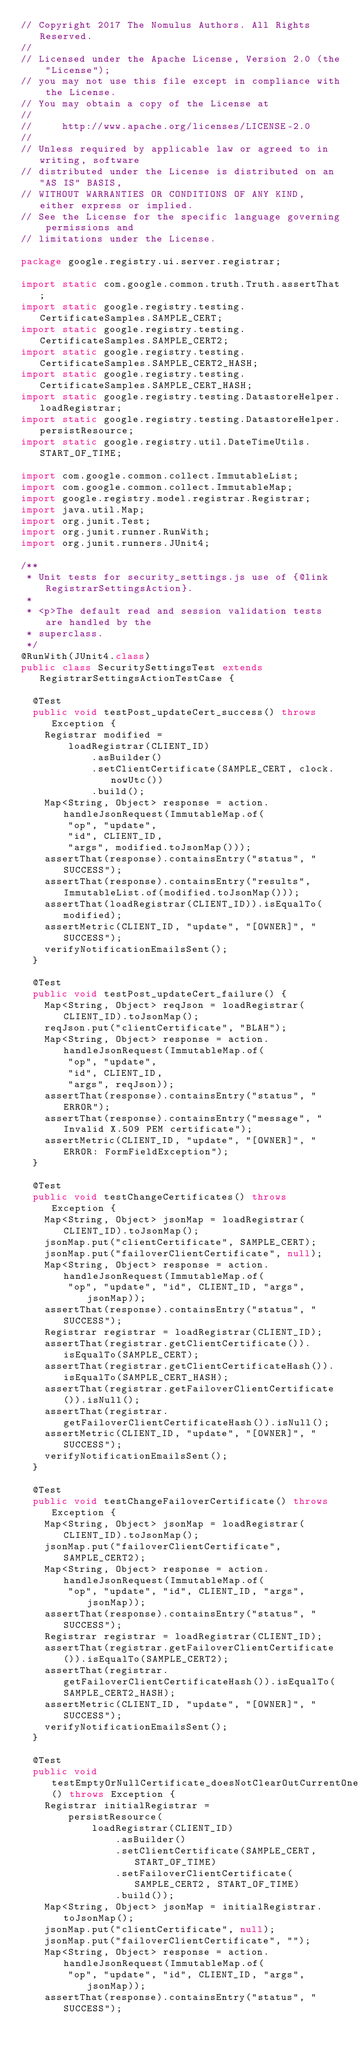Convert code to text. <code><loc_0><loc_0><loc_500><loc_500><_Java_>// Copyright 2017 The Nomulus Authors. All Rights Reserved.
//
// Licensed under the Apache License, Version 2.0 (the "License");
// you may not use this file except in compliance with the License.
// You may obtain a copy of the License at
//
//     http://www.apache.org/licenses/LICENSE-2.0
//
// Unless required by applicable law or agreed to in writing, software
// distributed under the License is distributed on an "AS IS" BASIS,
// WITHOUT WARRANTIES OR CONDITIONS OF ANY KIND, either express or implied.
// See the License for the specific language governing permissions and
// limitations under the License.

package google.registry.ui.server.registrar;

import static com.google.common.truth.Truth.assertThat;
import static google.registry.testing.CertificateSamples.SAMPLE_CERT;
import static google.registry.testing.CertificateSamples.SAMPLE_CERT2;
import static google.registry.testing.CertificateSamples.SAMPLE_CERT2_HASH;
import static google.registry.testing.CertificateSamples.SAMPLE_CERT_HASH;
import static google.registry.testing.DatastoreHelper.loadRegistrar;
import static google.registry.testing.DatastoreHelper.persistResource;
import static google.registry.util.DateTimeUtils.START_OF_TIME;

import com.google.common.collect.ImmutableList;
import com.google.common.collect.ImmutableMap;
import google.registry.model.registrar.Registrar;
import java.util.Map;
import org.junit.Test;
import org.junit.runner.RunWith;
import org.junit.runners.JUnit4;

/**
 * Unit tests for security_settings.js use of {@link RegistrarSettingsAction}.
 *
 * <p>The default read and session validation tests are handled by the
 * superclass.
 */
@RunWith(JUnit4.class)
public class SecuritySettingsTest extends RegistrarSettingsActionTestCase {

  @Test
  public void testPost_updateCert_success() throws Exception {
    Registrar modified =
        loadRegistrar(CLIENT_ID)
            .asBuilder()
            .setClientCertificate(SAMPLE_CERT, clock.nowUtc())
            .build();
    Map<String, Object> response = action.handleJsonRequest(ImmutableMap.of(
        "op", "update",
        "id", CLIENT_ID,
        "args", modified.toJsonMap()));
    assertThat(response).containsEntry("status", "SUCCESS");
    assertThat(response).containsEntry("results", ImmutableList.of(modified.toJsonMap()));
    assertThat(loadRegistrar(CLIENT_ID)).isEqualTo(modified);
    assertMetric(CLIENT_ID, "update", "[OWNER]", "SUCCESS");
    verifyNotificationEmailsSent();
  }

  @Test
  public void testPost_updateCert_failure() {
    Map<String, Object> reqJson = loadRegistrar(CLIENT_ID).toJsonMap();
    reqJson.put("clientCertificate", "BLAH");
    Map<String, Object> response = action.handleJsonRequest(ImmutableMap.of(
        "op", "update",
        "id", CLIENT_ID,
        "args", reqJson));
    assertThat(response).containsEntry("status", "ERROR");
    assertThat(response).containsEntry("message", "Invalid X.509 PEM certificate");
    assertMetric(CLIENT_ID, "update", "[OWNER]", "ERROR: FormFieldException");
  }

  @Test
  public void testChangeCertificates() throws Exception {
    Map<String, Object> jsonMap = loadRegistrar(CLIENT_ID).toJsonMap();
    jsonMap.put("clientCertificate", SAMPLE_CERT);
    jsonMap.put("failoverClientCertificate", null);
    Map<String, Object> response = action.handleJsonRequest(ImmutableMap.of(
        "op", "update", "id", CLIENT_ID, "args", jsonMap));
    assertThat(response).containsEntry("status", "SUCCESS");
    Registrar registrar = loadRegistrar(CLIENT_ID);
    assertThat(registrar.getClientCertificate()).isEqualTo(SAMPLE_CERT);
    assertThat(registrar.getClientCertificateHash()).isEqualTo(SAMPLE_CERT_HASH);
    assertThat(registrar.getFailoverClientCertificate()).isNull();
    assertThat(registrar.getFailoverClientCertificateHash()).isNull();
    assertMetric(CLIENT_ID, "update", "[OWNER]", "SUCCESS");
    verifyNotificationEmailsSent();
  }

  @Test
  public void testChangeFailoverCertificate() throws Exception {
    Map<String, Object> jsonMap = loadRegistrar(CLIENT_ID).toJsonMap();
    jsonMap.put("failoverClientCertificate", SAMPLE_CERT2);
    Map<String, Object> response = action.handleJsonRequest(ImmutableMap.of(
        "op", "update", "id", CLIENT_ID, "args", jsonMap));
    assertThat(response).containsEntry("status", "SUCCESS");
    Registrar registrar = loadRegistrar(CLIENT_ID);
    assertThat(registrar.getFailoverClientCertificate()).isEqualTo(SAMPLE_CERT2);
    assertThat(registrar.getFailoverClientCertificateHash()).isEqualTo(SAMPLE_CERT2_HASH);
    assertMetric(CLIENT_ID, "update", "[OWNER]", "SUCCESS");
    verifyNotificationEmailsSent();
  }

  @Test
  public void testEmptyOrNullCertificate_doesNotClearOutCurrentOne() throws Exception {
    Registrar initialRegistrar =
        persistResource(
            loadRegistrar(CLIENT_ID)
                .asBuilder()
                .setClientCertificate(SAMPLE_CERT, START_OF_TIME)
                .setFailoverClientCertificate(SAMPLE_CERT2, START_OF_TIME)
                .build());
    Map<String, Object> jsonMap = initialRegistrar.toJsonMap();
    jsonMap.put("clientCertificate", null);
    jsonMap.put("failoverClientCertificate", "");
    Map<String, Object> response = action.handleJsonRequest(ImmutableMap.of(
        "op", "update", "id", CLIENT_ID, "args", jsonMap));
    assertThat(response).containsEntry("status", "SUCCESS");</code> 